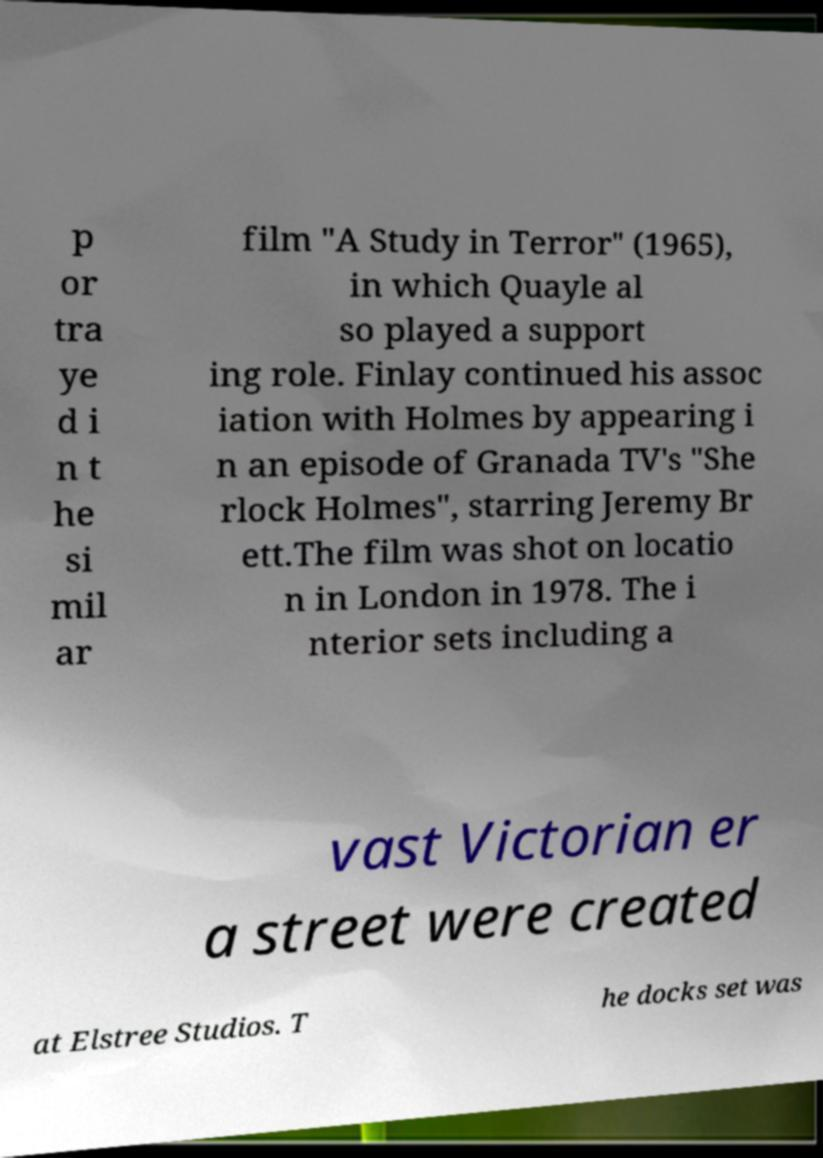There's text embedded in this image that I need extracted. Can you transcribe it verbatim? p or tra ye d i n t he si mil ar film "A Study in Terror" (1965), in which Quayle al so played a support ing role. Finlay continued his assoc iation with Holmes by appearing i n an episode of Granada TV's "She rlock Holmes", starring Jeremy Br ett.The film was shot on locatio n in London in 1978. The i nterior sets including a vast Victorian er a street were created at Elstree Studios. T he docks set was 